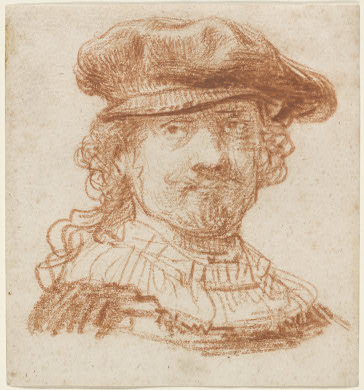What can you tell me about the historical context of this drawing? Considering the Baroque art style indicated by the dramatic intensity and strong contrasts, this drawing likely originates from the 17th century. During this period, portraiture was a prominent genre, often commissioned by wealthy patrons to capture the likeness of individuals in a dignified manner. The use of red chalk was a popular medium among artists like Rembrandt and others, allowing for detailed and expressive lines that brought characters to life. The hat and ruff collar were fashionable during the time, indicative of the sitter's social standing and taste. Can you speculate who might have commissioned such a portrait? Given the elegance of the attire and the skilled execution of the portrait, it is plausible that this drawing was commissioned by a person of considerable wealth and status. In 17th century Europe, such commissions were often made by nobles, wealthy merchants, or influential cultural figures who sought to immortalize their presence and status through art. The presence of a hat and ruff collar suggests that the individual portrayed was fashionable and likely held a significant social position. What emotions or thoughts do you think the artist wanted to convey through this portrait? The artist seems to convey a sense of dignity and introspection through the subject's calm yet assertive expression. The slightly tilted head and the elaborate clothing may suggest a thoughtful demeanor, inviting viewers to ponder the character and life of the portrayed individual. The warm tones of the red chalk and the textured strokes point towards an appreciation for realism and depth, suggesting that the artist aimed to create a lifelike, almost intimate connection between the viewer and the subject. The Baroque style's emphasis on contrast and emotion further reinforces the dramatic and nuanced portrayal of the sitter's identity and status. Imagine this portrait could speak; what story would it tell about the person portrayed? If this portrait could speak, it might tell the story of a man who lived a life of both privilege and duty. He could share tales of his role in society, perhaps as a merchant or a nobleman, describing the challenges and triumphs he faced. The hat and ruff collar would echo the fashion and elegance of his time, suggesting that he was a person who valued appearance and tradition. He might recount his interactions with other influential figures of his era, revealing the intricate social and economic networks of 17th century Europe. This portrait could also express his personal reflections, his aspirations, and his contemplations about the world around him, all captured through the thoughtful gaze and the careful rendering by the artist. 